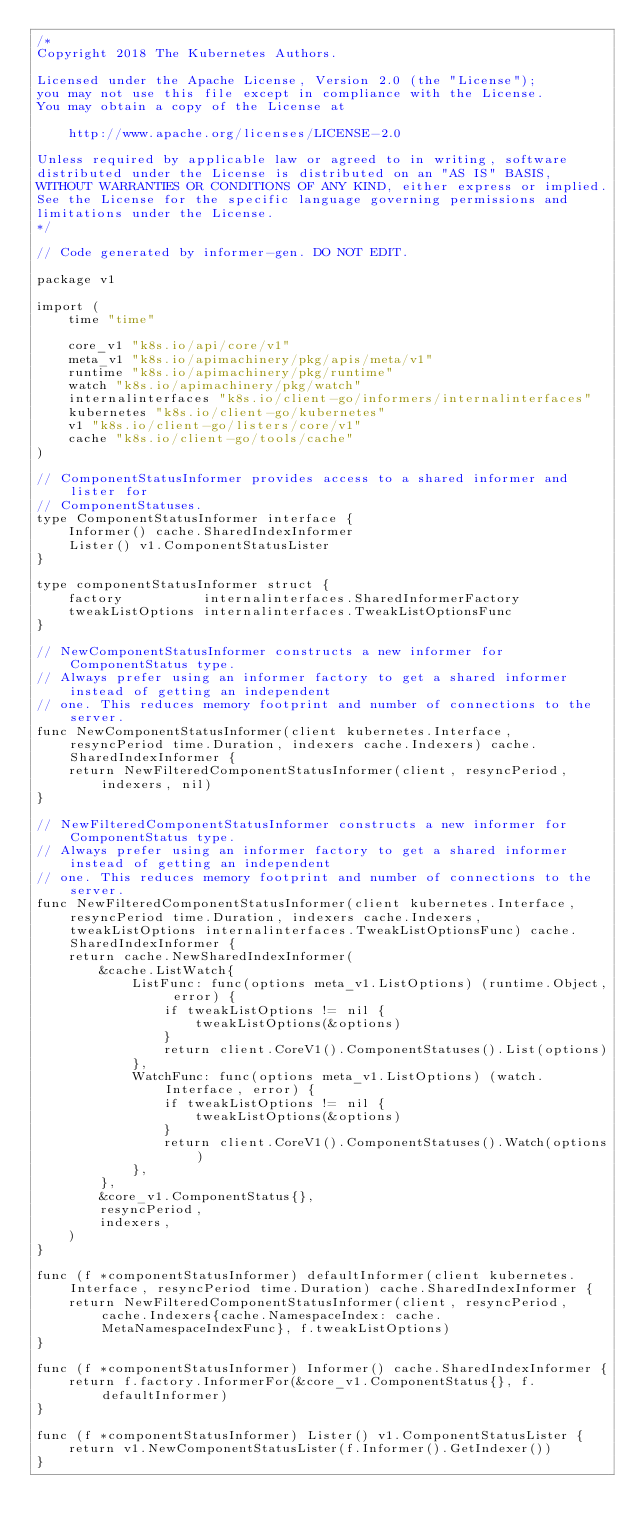Convert code to text. <code><loc_0><loc_0><loc_500><loc_500><_Go_>/*
Copyright 2018 The Kubernetes Authors.

Licensed under the Apache License, Version 2.0 (the "License");
you may not use this file except in compliance with the License.
You may obtain a copy of the License at

    http://www.apache.org/licenses/LICENSE-2.0

Unless required by applicable law or agreed to in writing, software
distributed under the License is distributed on an "AS IS" BASIS,
WITHOUT WARRANTIES OR CONDITIONS OF ANY KIND, either express or implied.
See the License for the specific language governing permissions and
limitations under the License.
*/

// Code generated by informer-gen. DO NOT EDIT.

package v1

import (
	time "time"

	core_v1 "k8s.io/api/core/v1"
	meta_v1 "k8s.io/apimachinery/pkg/apis/meta/v1"
	runtime "k8s.io/apimachinery/pkg/runtime"
	watch "k8s.io/apimachinery/pkg/watch"
	internalinterfaces "k8s.io/client-go/informers/internalinterfaces"
	kubernetes "k8s.io/client-go/kubernetes"
	v1 "k8s.io/client-go/listers/core/v1"
	cache "k8s.io/client-go/tools/cache"
)

// ComponentStatusInformer provides access to a shared informer and lister for
// ComponentStatuses.
type ComponentStatusInformer interface {
	Informer() cache.SharedIndexInformer
	Lister() v1.ComponentStatusLister
}

type componentStatusInformer struct {
	factory          internalinterfaces.SharedInformerFactory
	tweakListOptions internalinterfaces.TweakListOptionsFunc
}

// NewComponentStatusInformer constructs a new informer for ComponentStatus type.
// Always prefer using an informer factory to get a shared informer instead of getting an independent
// one. This reduces memory footprint and number of connections to the server.
func NewComponentStatusInformer(client kubernetes.Interface, resyncPeriod time.Duration, indexers cache.Indexers) cache.SharedIndexInformer {
	return NewFilteredComponentStatusInformer(client, resyncPeriod, indexers, nil)
}

// NewFilteredComponentStatusInformer constructs a new informer for ComponentStatus type.
// Always prefer using an informer factory to get a shared informer instead of getting an independent
// one. This reduces memory footprint and number of connections to the server.
func NewFilteredComponentStatusInformer(client kubernetes.Interface, resyncPeriod time.Duration, indexers cache.Indexers, tweakListOptions internalinterfaces.TweakListOptionsFunc) cache.SharedIndexInformer {
	return cache.NewSharedIndexInformer(
		&cache.ListWatch{
			ListFunc: func(options meta_v1.ListOptions) (runtime.Object, error) {
				if tweakListOptions != nil {
					tweakListOptions(&options)
				}
				return client.CoreV1().ComponentStatuses().List(options)
			},
			WatchFunc: func(options meta_v1.ListOptions) (watch.Interface, error) {
				if tweakListOptions != nil {
					tweakListOptions(&options)
				}
				return client.CoreV1().ComponentStatuses().Watch(options)
			},
		},
		&core_v1.ComponentStatus{},
		resyncPeriod,
		indexers,
	)
}

func (f *componentStatusInformer) defaultInformer(client kubernetes.Interface, resyncPeriod time.Duration) cache.SharedIndexInformer {
	return NewFilteredComponentStatusInformer(client, resyncPeriod, cache.Indexers{cache.NamespaceIndex: cache.MetaNamespaceIndexFunc}, f.tweakListOptions)
}

func (f *componentStatusInformer) Informer() cache.SharedIndexInformer {
	return f.factory.InformerFor(&core_v1.ComponentStatus{}, f.defaultInformer)
}

func (f *componentStatusInformer) Lister() v1.ComponentStatusLister {
	return v1.NewComponentStatusLister(f.Informer().GetIndexer())
}
</code> 